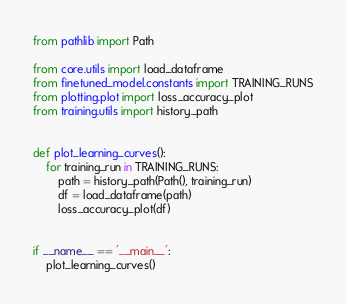<code> <loc_0><loc_0><loc_500><loc_500><_Python_>from pathlib import Path

from core.utils import load_dataframe
from finetuned_model.constants import TRAINING_RUNS
from plotting.plot import loss_accuracy_plot
from training.utils import history_path


def plot_learning_curves():
    for training_run in TRAINING_RUNS:
        path = history_path(Path(), training_run)
        df = load_dataframe(path)
        loss_accuracy_plot(df)


if __name__ == '__main__':
    plot_learning_curves()
</code> 